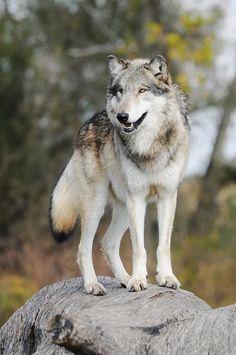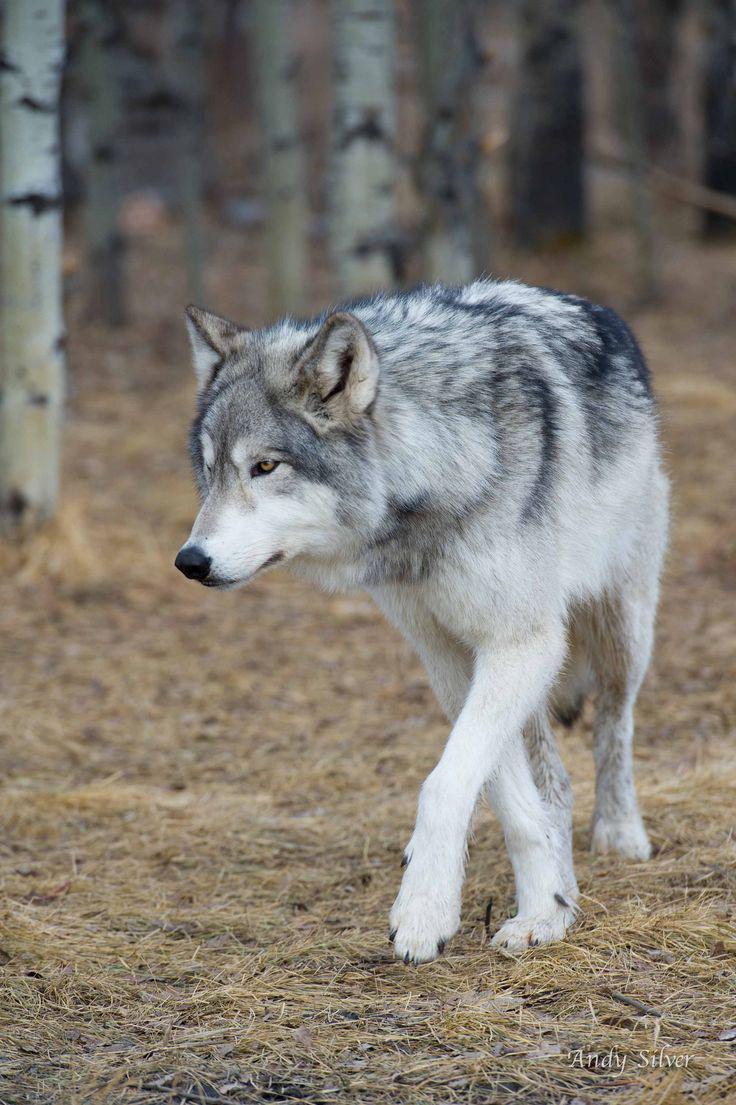The first image is the image on the left, the second image is the image on the right. For the images displayed, is the sentence "An image shows a wolf walking forward, in the general direction of the camera." factually correct? Answer yes or no. Yes. 